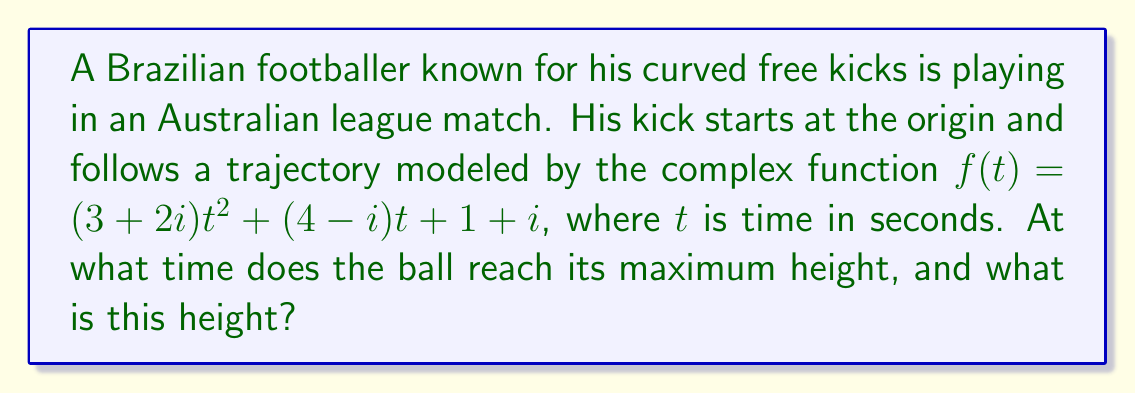Teach me how to tackle this problem. Let's approach this step-by-step:

1) The trajectory is given by $f(t) = (3+2i)t^2 + (4-i)t + 1+i$

2) The imaginary part of this function represents the height of the ball. Let's call this $y(t)$:
   $y(t) = 2t^2 - t + 1$

3) To find the maximum height, we need to find where $\frac{dy}{dt} = 0$:
   $\frac{dy}{dt} = 4t - 1$

4) Setting this equal to zero:
   $4t - 1 = 0$
   $4t = 1$
   $t = \frac{1}{4}$

5) To confirm this is a maximum (not a minimum), we can check the second derivative:
   $\frac{d^2y}{dt^2} = 4$, which is positive, confirming a maximum.

6) Now that we know the time, we can calculate the maximum height by plugging $t = \frac{1}{4}$ back into $y(t)$:

   $y(\frac{1}{4}) = 2(\frac{1}{4})^2 - \frac{1}{4} + 1$
                   $= 2(\frac{1}{16}) - \frac{1}{4} + 1$
                   $= \frac{1}{8} - \frac{1}{4} + 1$
                   $= \frac{1}{8} - \frac{2}{8} + \frac{8}{8}$
                   $= \frac{7}{8}$

Therefore, the ball reaches its maximum height at $t = \frac{1}{4}$ seconds, and the maximum height is $\frac{7}{8}$ units.
Answer: $t = \frac{1}{4}$ seconds, height = $\frac{7}{8}$ units 